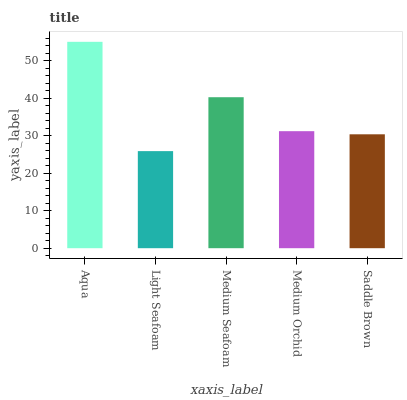Is Light Seafoam the minimum?
Answer yes or no. Yes. Is Aqua the maximum?
Answer yes or no. Yes. Is Medium Seafoam the minimum?
Answer yes or no. No. Is Medium Seafoam the maximum?
Answer yes or no. No. Is Medium Seafoam greater than Light Seafoam?
Answer yes or no. Yes. Is Light Seafoam less than Medium Seafoam?
Answer yes or no. Yes. Is Light Seafoam greater than Medium Seafoam?
Answer yes or no. No. Is Medium Seafoam less than Light Seafoam?
Answer yes or no. No. Is Medium Orchid the high median?
Answer yes or no. Yes. Is Medium Orchid the low median?
Answer yes or no. Yes. Is Saddle Brown the high median?
Answer yes or no. No. Is Aqua the low median?
Answer yes or no. No. 